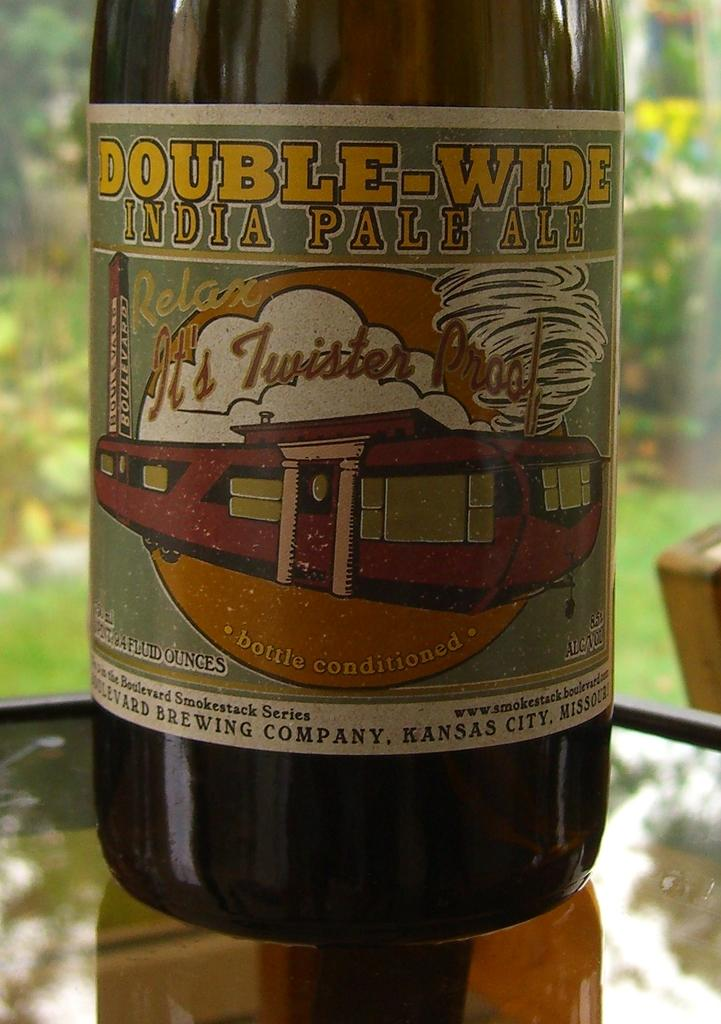<image>
Present a compact description of the photo's key features. A bottle of double wide India pale ale.sits in front of a window. 